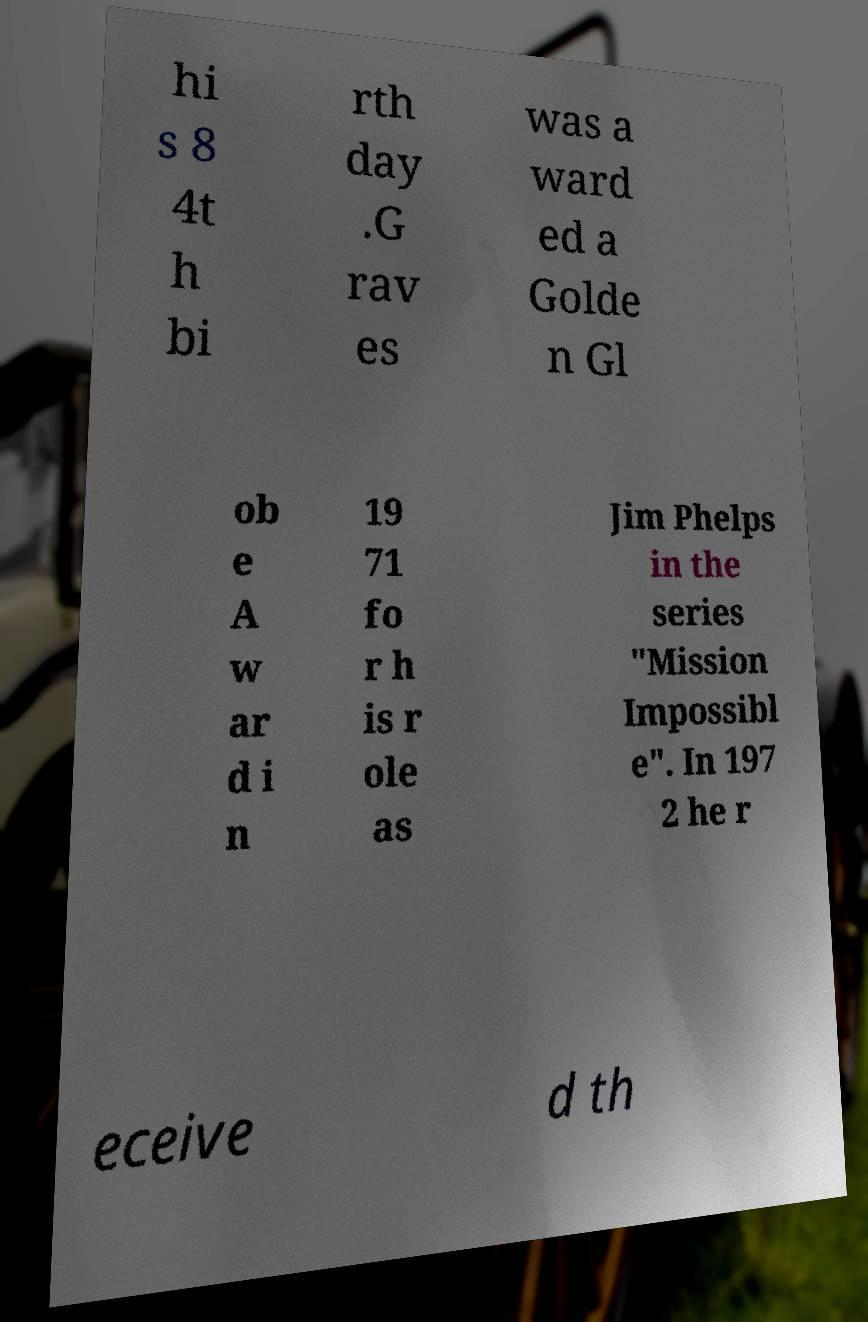I need the written content from this picture converted into text. Can you do that? hi s 8 4t h bi rth day .G rav es was a ward ed a Golde n Gl ob e A w ar d i n 19 71 fo r h is r ole as Jim Phelps in the series "Mission Impossibl e". In 197 2 he r eceive d th 